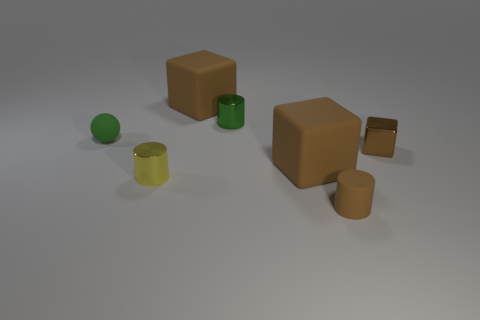Subtract all brown blocks. How many were subtracted if there are1brown blocks left? 2 Subtract all large cubes. How many cubes are left? 1 Subtract 1 cubes. How many cubes are left? 2 Add 1 large yellow metallic cubes. How many objects exist? 8 Subtract all cubes. How many objects are left? 4 Add 7 tiny yellow shiny objects. How many tiny yellow shiny objects exist? 8 Subtract 0 brown balls. How many objects are left? 7 Subtract all green cubes. Subtract all yellow spheres. How many cubes are left? 3 Subtract all small brown cylinders. Subtract all shiny cubes. How many objects are left? 5 Add 6 metallic cubes. How many metallic cubes are left? 7 